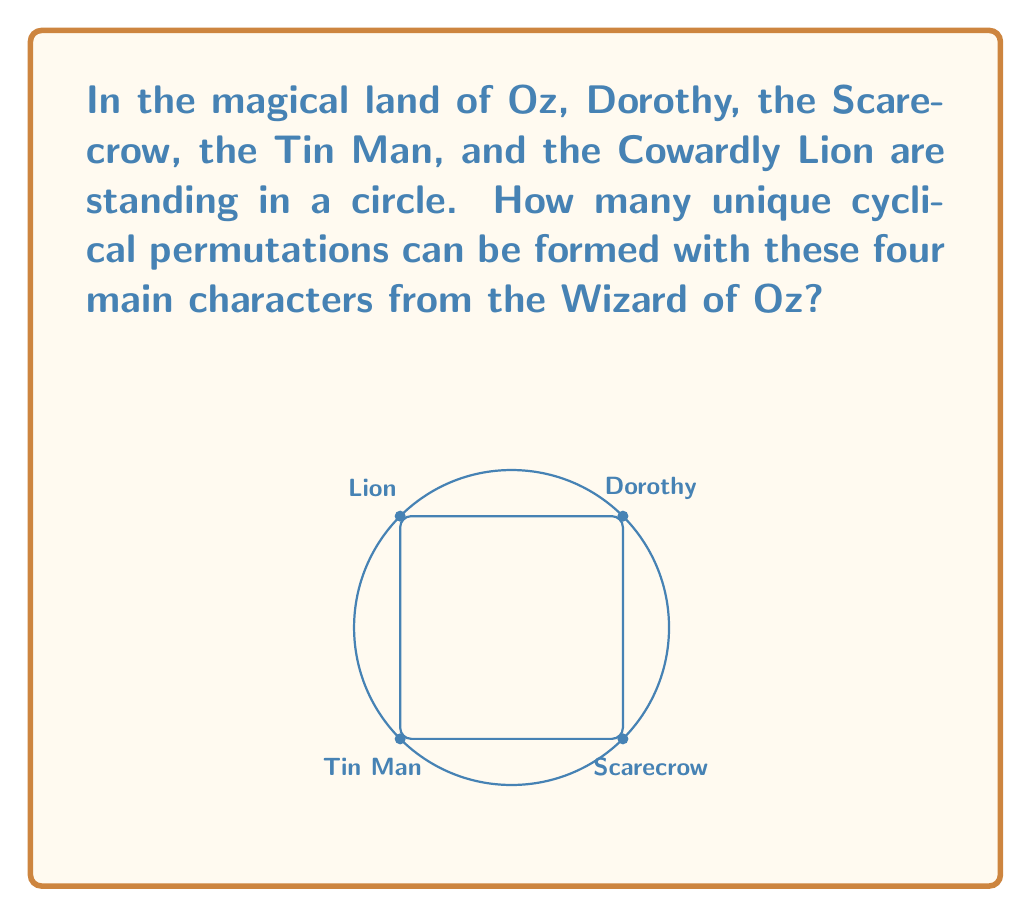Solve this math problem. Let's approach this step-by-step:

1) First, we need to understand what a cyclical permutation is. In a cyclical permutation, we consider rotations of the same arrangement as identical. For example, (Dorothy, Scarecrow, Tin Man, Lion) is considered the same as (Scarecrow, Tin Man, Lion, Dorothy).

2) For a set of $n$ distinct elements, the number of unique cyclical permutations is given by $(n-1)!$.

3) In this case, we have 4 characters: Dorothy, Scarecrow, Tin Man, and Lion. So, $n = 4$.

4) Applying the formula:
   Number of unique cyclical permutations $= (4-1)! = 3!$

5) Calculate $3!$:
   $3! = 3 \times 2 \times 1 = 6$

Therefore, there are 6 unique cyclical permutations of the four main characters from the Wizard of Oz.

These permutations are:
1. (Dorothy, Scarecrow, Tin Man, Lion)
2. (Dorothy, Scarecrow, Lion, Tin Man)
3. (Dorothy, Tin Man, Scarecrow, Lion)
4. (Dorothy, Tin Man, Lion, Scarecrow)
5. (Dorothy, Lion, Scarecrow, Tin Man)
6. (Dorothy, Lion, Tin Man, Scarecrow)

Note that rotations of these are considered identical in cyclical permutations.
Answer: $6$ 